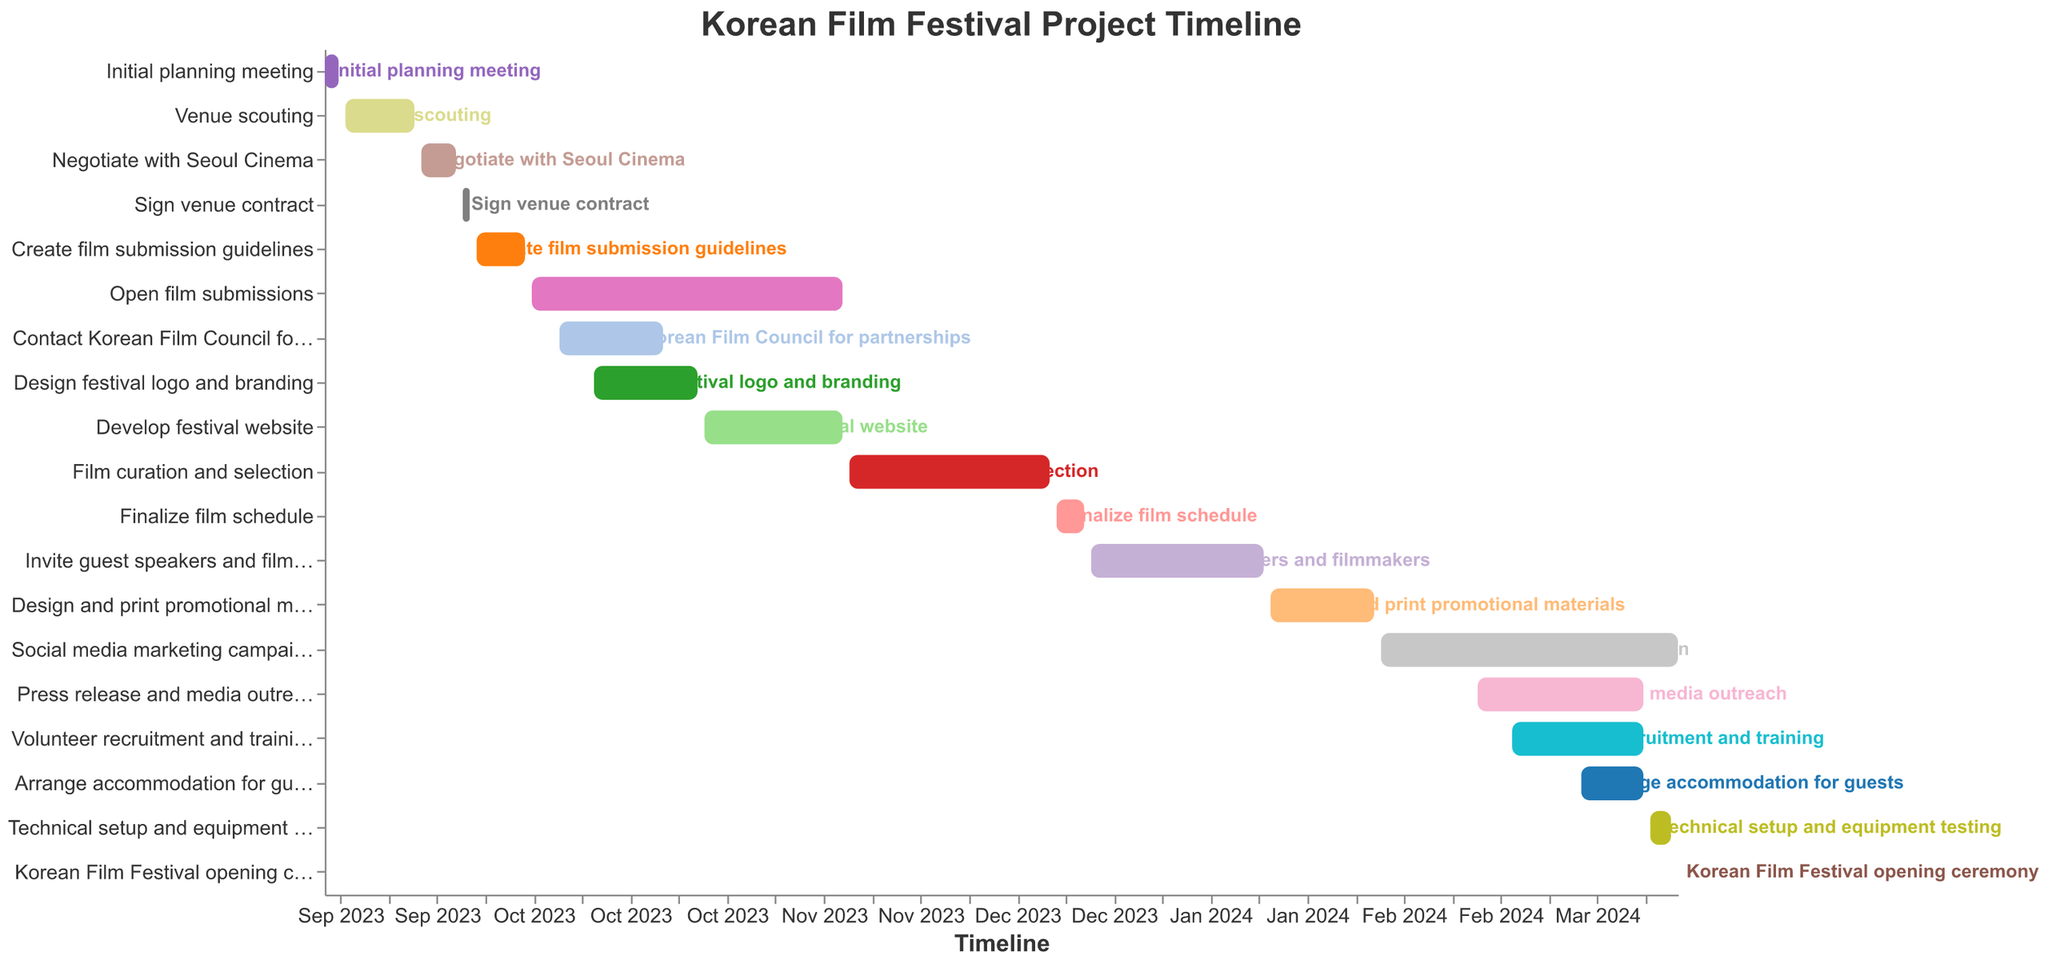what is the title of the project timeline? The title is displayed prominently at the top of the chart in bold and larger font size.
Answer: Korean Film Festival Project Timeline What is the first task in the project timeline and its duration? The first task is "Initial planning meeting," and it starts on September 1, 2023, and ends on September 3, 2023. The duration can be calculated by subtracting the start date from the end date.
Answer: Initial planning meeting, 2 days When does the "Social media marketing campaign" start and how long does it last? The "Social media marketing campaign" starts on February 1, 2024, and ends on March 15, 2024. The duration is from February 1, 2024, to March 15, 2024.
Answer: February 1, 2024, 43 days Which task has the shortest duration, and how many days does it span? "Sign venue contract" has the shortest duration, starting on September 21, 2023, and ending on September 22, 2023. The duration is calculated by subtracting the start date from the end date.
Answer: Sign venue contract, 1 day Compare the durations of the "Open film submissions" task and the "Volunteer recruitment and training" task. Which one is longer and by how many days? "Open film submissions" runs from October 1, 2023, to November 15, 2023, and "Volunteer recruitment and training" from February 20, 2024, to March 10, 2024. The duration comparison shows that "Open film submissions" is longer.
Answer: Open film submissions is longer by 37 days When does the task "Design festival logo and branding" end and what is the next task that starts after this one? "Design festival logo and branding" ends on October 25, 2023. The next task that starts after this one is "Develop festival website," which starts on October 26, 2023.
Answer: October 25, 2023, Develop festival website How many tasks span into the year 2024? By analyzing the timeline, identify the tasks that start in 2023 and end in 2024 or those that start and end in 2024.
Answer: 7 tasks Identify any tasks that overlap with "Press release and media outreach." "Press release and media outreach" starts on February 15, 2024, and ends on March 10, 2024. Overlapping tasks can be determined by examining the timeline for other tasks occurring during this period.
Answer: Social media marketing campaign, Volunteer recruitment and training, Arrange accommodation for guests Calculate the total duration for the task "Invite guest speakers and filmmakers". This task starts on December 21, 2023, and ends on January 15, 2024. The total duration is calculated by subtracting the start date from the end date.
Answer: 26 days Which task ends just one day before the "Korean Film Festival opening ceremony"? The "Korean Film Festival opening ceremony" is on March 15, 2024. The task that ends on March 14, 2024, is "Technical setup and equipment testing."
Answer: Technical setup and equipment testing 